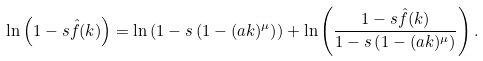<formula> <loc_0><loc_0><loc_500><loc_500>\ln \left ( 1 - s { \hat { f } } ( k ) \right ) = \ln \left ( 1 - s \left ( 1 - ( a k ) ^ { \mu } \right ) \right ) + \ln \left ( \frac { 1 - s { \hat { f } } ( k ) } { 1 - s \left ( 1 - ( a k ) ^ { \mu } \right ) } \right ) .</formula> 